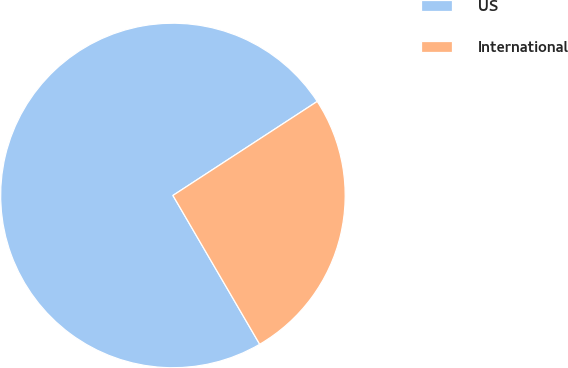Convert chart to OTSL. <chart><loc_0><loc_0><loc_500><loc_500><pie_chart><fcel>US<fcel>International<nl><fcel>74.21%<fcel>25.79%<nl></chart> 